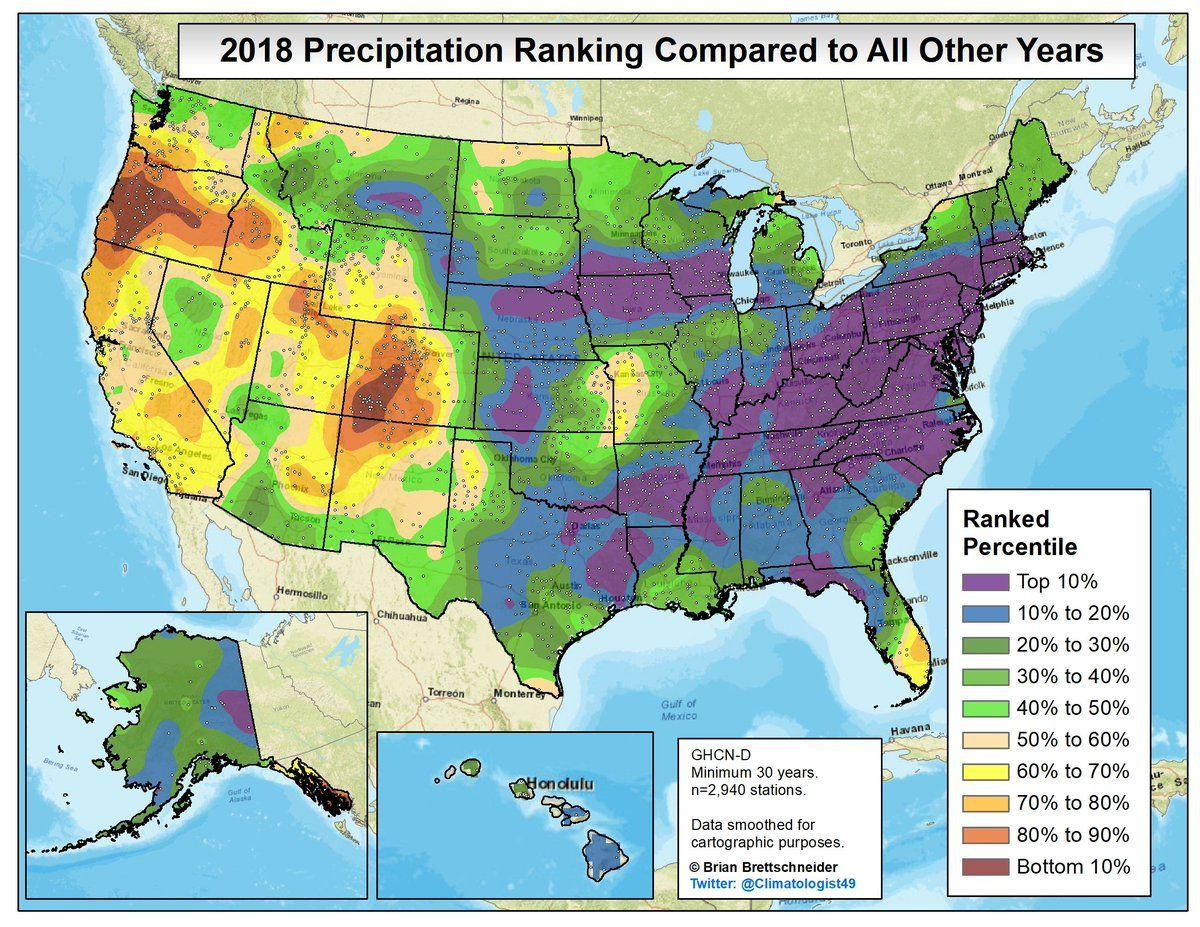Draw attention to some important aspects in this diagram. Honolulu can be divided into two regions based on precipitation ranking. The color purple depicts the top 10% of precipitation ranking. Based on the precipitation ranking, Alaska can be divided into three regions. The range of values in the ranked percentile indicates the distribution of scores for a particular percentile range, from the bottom 10% to the top 10%. The color that represents the bottom 10% precipitation ranking is red. 